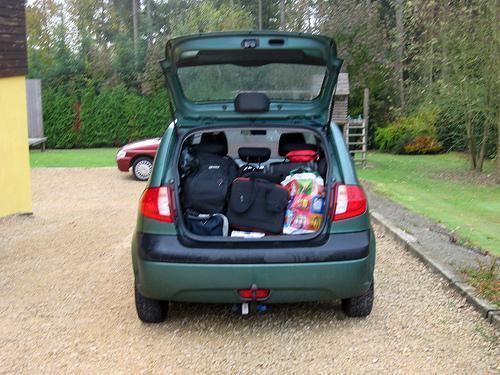How many vehicles are there?
Give a very brief answer. 2. 